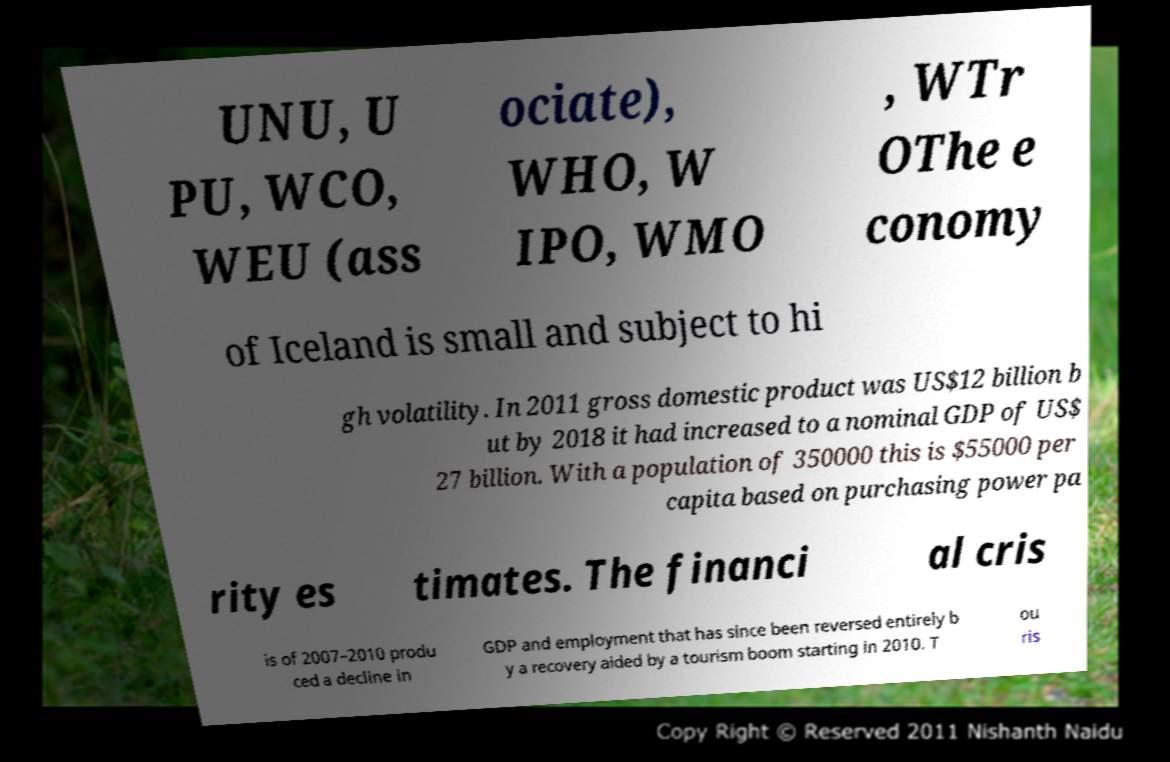Can you read and provide the text displayed in the image?This photo seems to have some interesting text. Can you extract and type it out for me? UNU, U PU, WCO, WEU (ass ociate), WHO, W IPO, WMO , WTr OThe e conomy of Iceland is small and subject to hi gh volatility. In 2011 gross domestic product was US$12 billion b ut by 2018 it had increased to a nominal GDP of US$ 27 billion. With a population of 350000 this is $55000 per capita based on purchasing power pa rity es timates. The financi al cris is of 2007–2010 produ ced a decline in GDP and employment that has since been reversed entirely b y a recovery aided by a tourism boom starting in 2010. T ou ris 